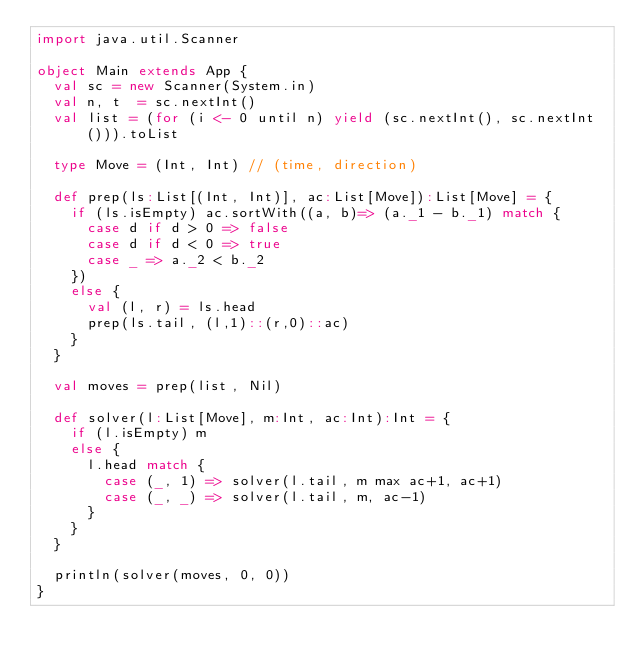<code> <loc_0><loc_0><loc_500><loc_500><_Scala_>import java.util.Scanner

object Main extends App { 
  val sc = new Scanner(System.in)
  val n, t  = sc.nextInt()
  val list = (for (i <- 0 until n) yield (sc.nextInt(), sc.nextInt())).toList

  type Move = (Int, Int) // (time, direction)

  def prep(ls:List[(Int, Int)], ac:List[Move]):List[Move] = {
    if (ls.isEmpty) ac.sortWith((a, b)=> (a._1 - b._1) match {
      case d if d > 0 => false
      case d if d < 0 => true
      case _ => a._2 < b._2  
    })
    else {
      val (l, r) = ls.head
      prep(ls.tail, (l,1)::(r,0)::ac)
    }
  }

  val moves = prep(list, Nil)

  def solver(l:List[Move], m:Int, ac:Int):Int = {
    if (l.isEmpty) m
    else {
      l.head match {
        case (_, 1) => solver(l.tail, m max ac+1, ac+1)
        case (_, _) => solver(l.tail, m, ac-1)
      }
    } 
  }

  println(solver(moves, 0, 0))
}

</code> 